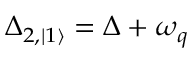<formula> <loc_0><loc_0><loc_500><loc_500>\Delta _ { 2 , | 1 \rangle } = \Delta + \omega _ { q }</formula> 